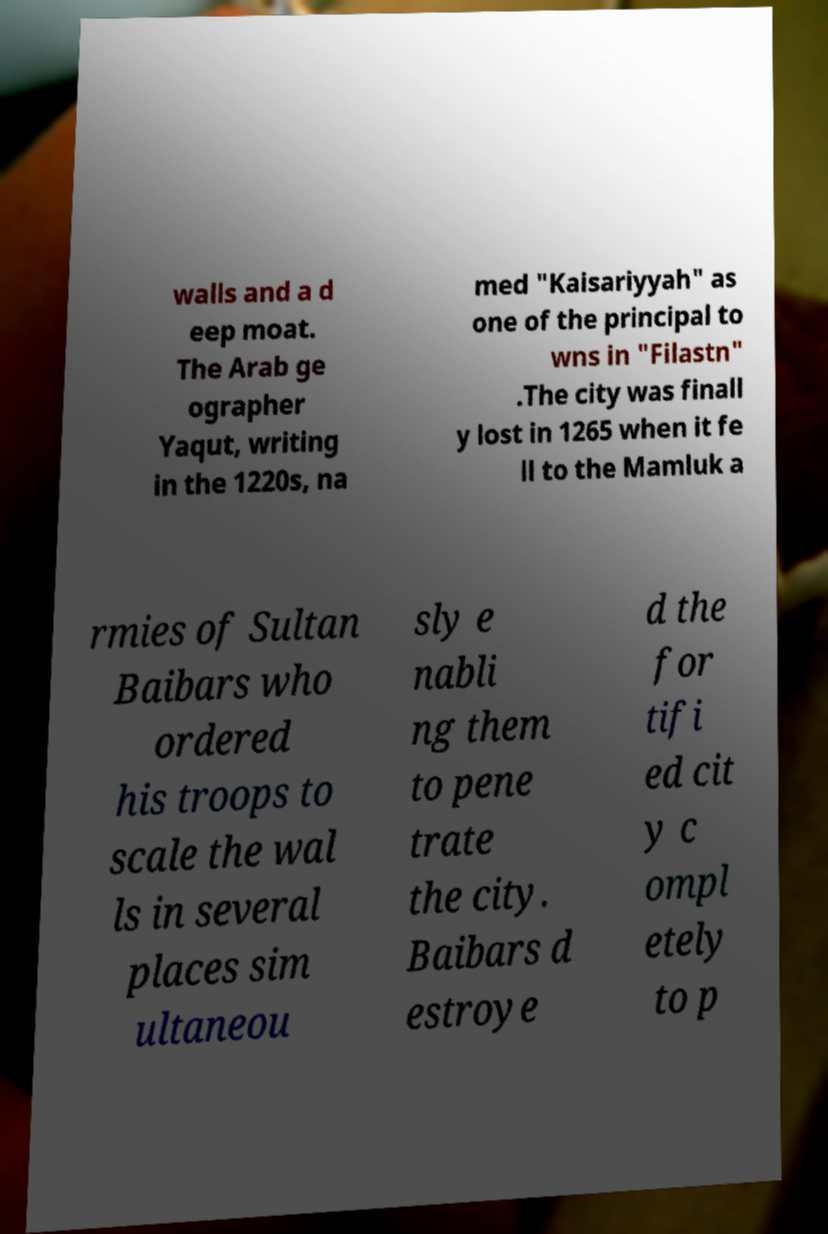What messages or text are displayed in this image? I need them in a readable, typed format. walls and a d eep moat. The Arab ge ographer Yaqut, writing in the 1220s, na med "Kaisariyyah" as one of the principal to wns in "Filastn" .The city was finall y lost in 1265 when it fe ll to the Mamluk a rmies of Sultan Baibars who ordered his troops to scale the wal ls in several places sim ultaneou sly e nabli ng them to pene trate the city. Baibars d estroye d the for tifi ed cit y c ompl etely to p 